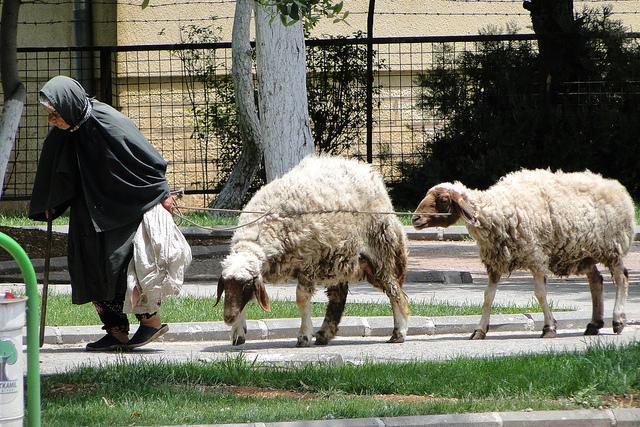Is the given caption "The sheep is connected to the person." fitting for the image?
Answer yes or no. Yes. Is the caption "The person is touching the sheep." a true representation of the image?
Answer yes or no. No. Is the caption "The person is connected to the sheep." a true representation of the image?
Answer yes or no. Yes. Verify the accuracy of this image caption: "The person is attached to the sheep.".
Answer yes or no. Yes. Is the given caption "The sheep is beneath the person." fitting for the image?
Answer yes or no. No. 